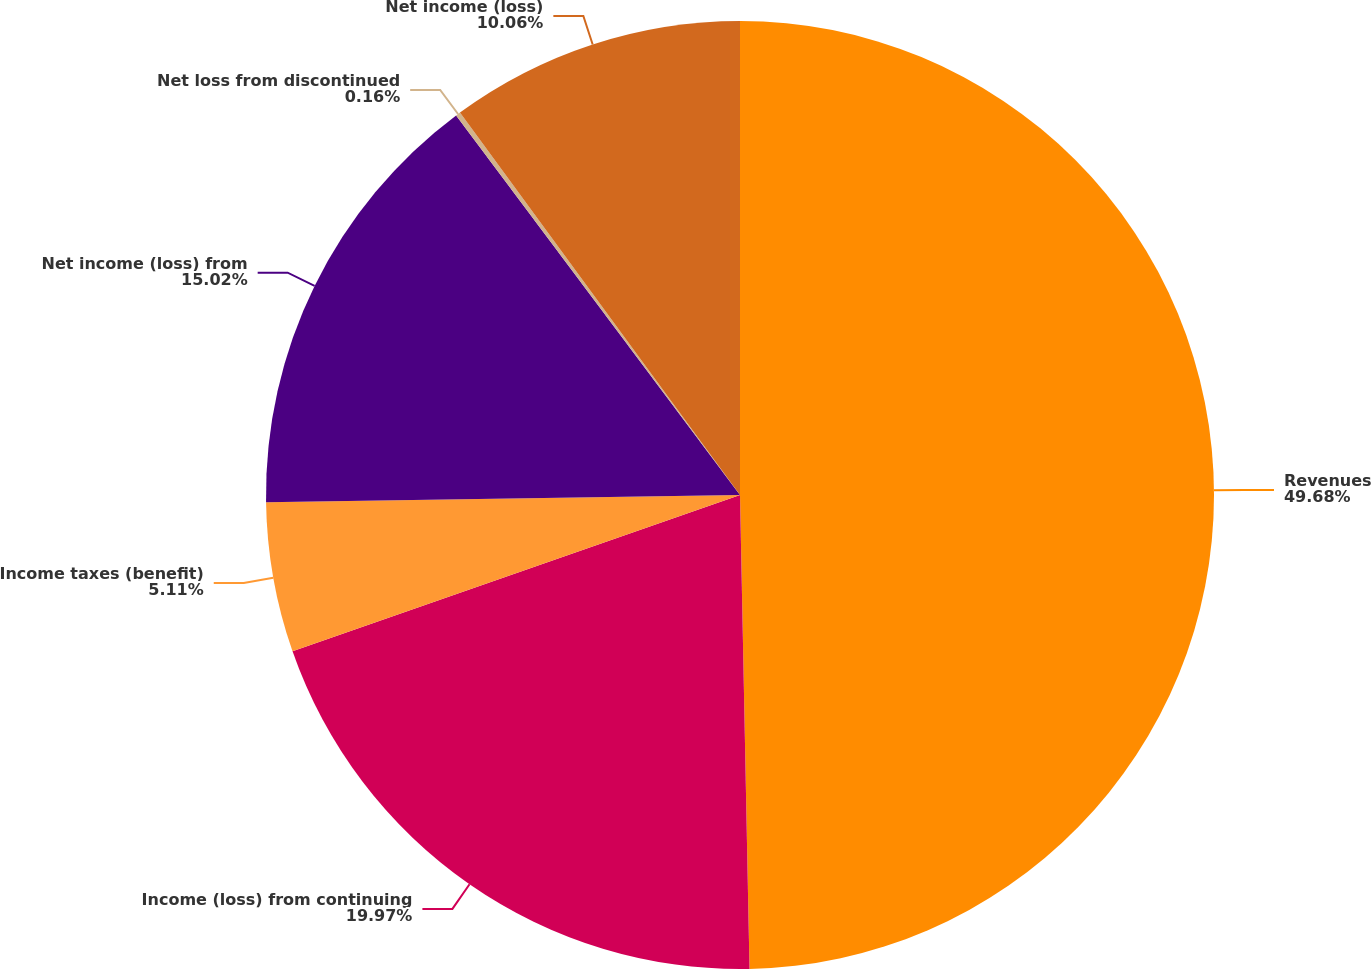<chart> <loc_0><loc_0><loc_500><loc_500><pie_chart><fcel>Revenues<fcel>Income (loss) from continuing<fcel>Income taxes (benefit)<fcel>Net income (loss) from<fcel>Net loss from discontinued<fcel>Net income (loss)<nl><fcel>49.68%<fcel>19.97%<fcel>5.11%<fcel>15.02%<fcel>0.16%<fcel>10.06%<nl></chart> 